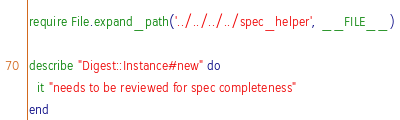Convert code to text. <code><loc_0><loc_0><loc_500><loc_500><_Ruby_>require File.expand_path('../../../../spec_helper', __FILE__)

describe "Digest::Instance#new" do
  it "needs to be reviewed for spec completeness"
end
</code> 